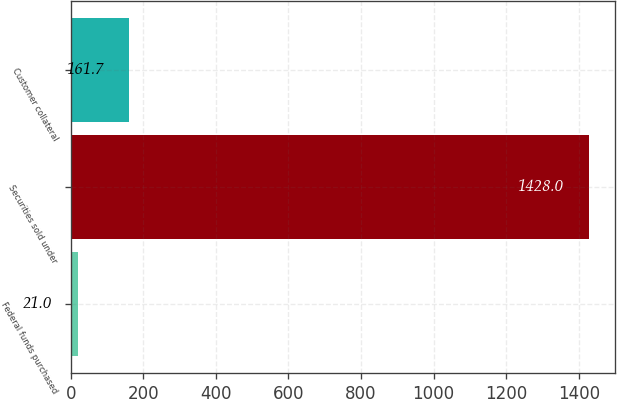<chart> <loc_0><loc_0><loc_500><loc_500><bar_chart><fcel>Federal funds purchased<fcel>Securities sold under<fcel>Customer collateral<nl><fcel>21<fcel>1428<fcel>161.7<nl></chart> 